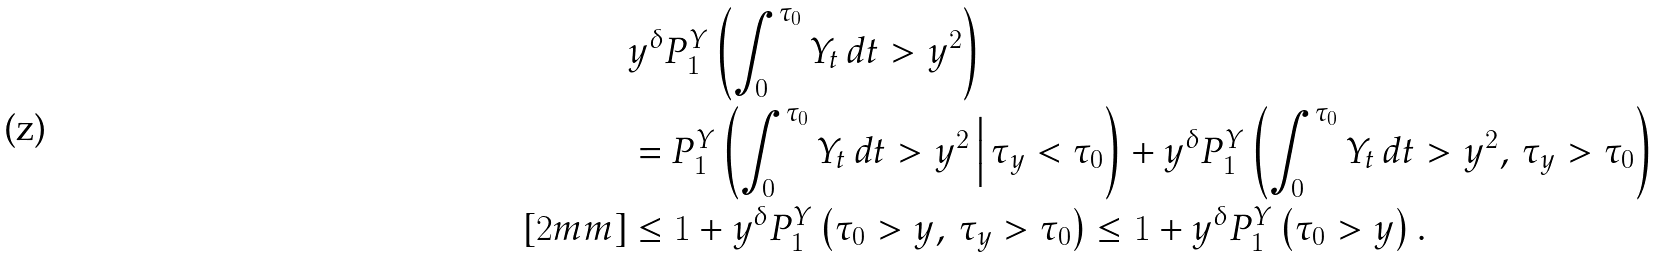<formula> <loc_0><loc_0><loc_500><loc_500>& y ^ { \delta } P _ { 1 } ^ { Y } \left ( \int _ { 0 } ^ { \tau _ { 0 } } Y _ { t } \, d t > y ^ { 2 } \right ) \\ & = P _ { 1 } ^ { Y } \left ( \int _ { 0 } ^ { \tau _ { 0 } } Y _ { t } \, d t > y ^ { 2 } \, \Big | \, \tau _ { y } < \tau _ { 0 } \right ) + y ^ { \delta } P _ { 1 } ^ { Y } \left ( \int _ { 0 } ^ { \tau _ { 0 } } Y _ { t } \, d t > y ^ { 2 } , \, \tau _ { y } > \tau _ { 0 } \right ) \\ [ 2 m m ] & \leq 1 + y ^ { \delta } P _ { 1 } ^ { Y } \left ( \tau _ { 0 } > y , \, \tau _ { y } > \tau _ { 0 } \right ) \leq 1 + y ^ { \delta } P _ { 1 } ^ { Y } \left ( \tau _ { 0 } > y \right ) .</formula> 